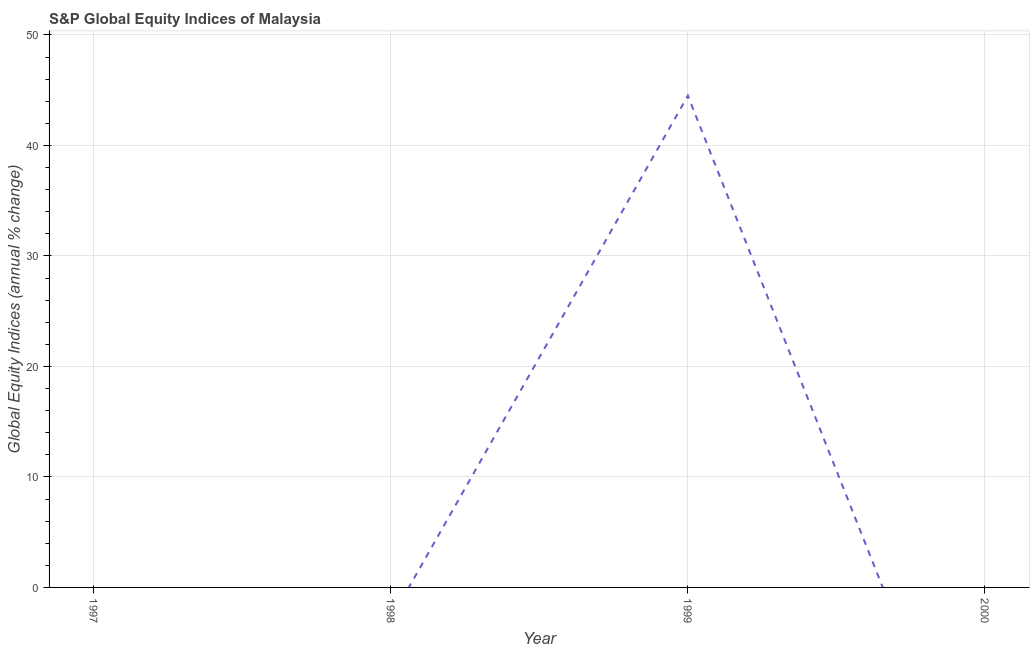What is the s&p global equity indices in 1998?
Offer a terse response. 0. Across all years, what is the maximum s&p global equity indices?
Offer a terse response. 44.5. In which year was the s&p global equity indices maximum?
Your answer should be very brief. 1999. What is the sum of the s&p global equity indices?
Offer a very short reply. 44.5. What is the average s&p global equity indices per year?
Your response must be concise. 11.12. What is the median s&p global equity indices?
Your answer should be compact. 0. In how many years, is the s&p global equity indices greater than 30 %?
Offer a terse response. 1. What is the difference between the highest and the lowest s&p global equity indices?
Your answer should be very brief. 44.5. How many years are there in the graph?
Keep it short and to the point. 4. What is the difference between two consecutive major ticks on the Y-axis?
Provide a short and direct response. 10. Are the values on the major ticks of Y-axis written in scientific E-notation?
Ensure brevity in your answer.  No. What is the title of the graph?
Provide a short and direct response. S&P Global Equity Indices of Malaysia. What is the label or title of the Y-axis?
Offer a very short reply. Global Equity Indices (annual % change). What is the Global Equity Indices (annual % change) of 1999?
Provide a short and direct response. 44.5. What is the Global Equity Indices (annual % change) of 2000?
Ensure brevity in your answer.  0. 